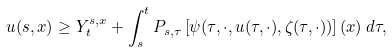<formula> <loc_0><loc_0><loc_500><loc_500>u ( s , x ) \geq Y _ { t } ^ { s , x } + \int _ { s } ^ { t } P _ { s , \tau } \left [ \psi ( \tau , \cdot , u ( \tau , \cdot ) , \zeta ( \tau , \cdot ) ) \right ] ( x ) \, d \tau ,</formula> 